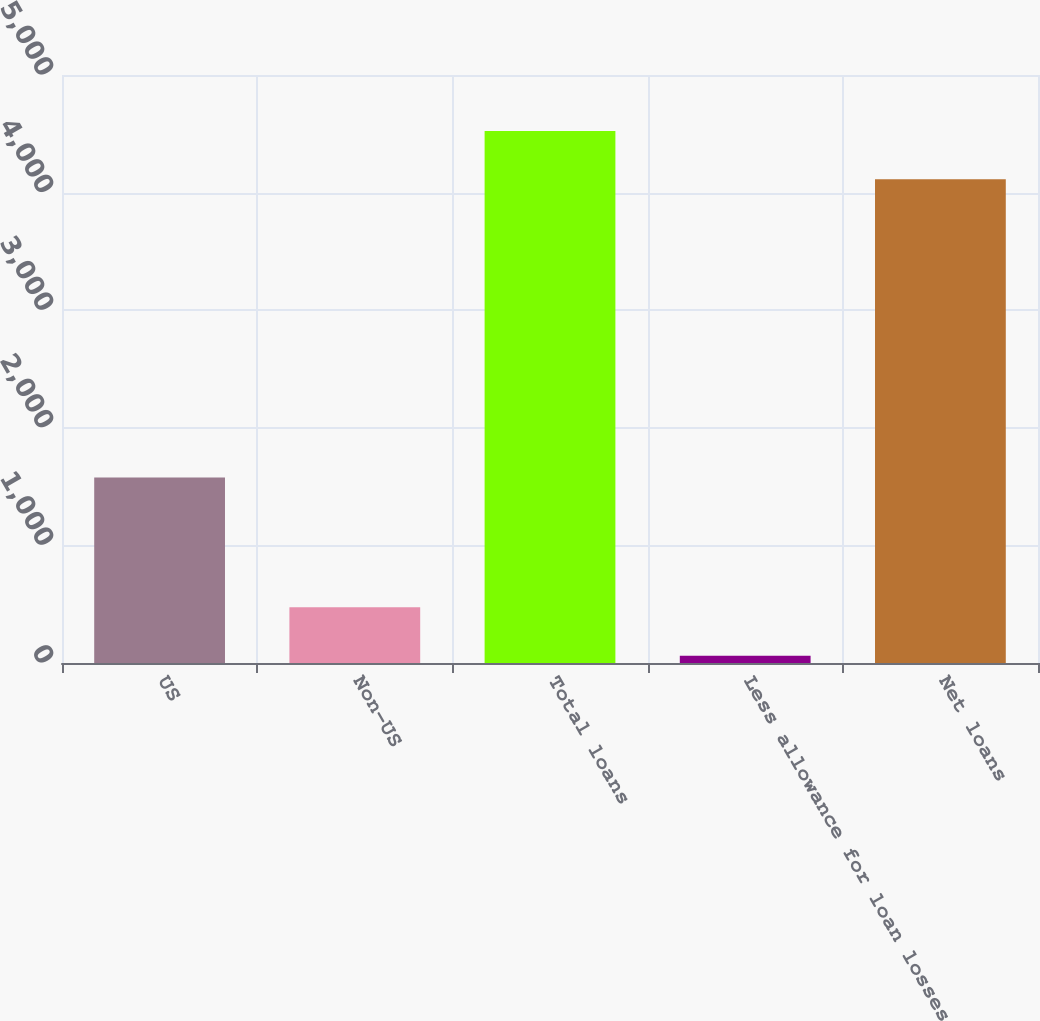Convert chart. <chart><loc_0><loc_0><loc_500><loc_500><bar_chart><fcel>US<fcel>Non-US<fcel>Total loans<fcel>Less allowance for loan losses<fcel>Net loans<nl><fcel>1578<fcel>474<fcel>4524.3<fcel>61<fcel>4113<nl></chart> 